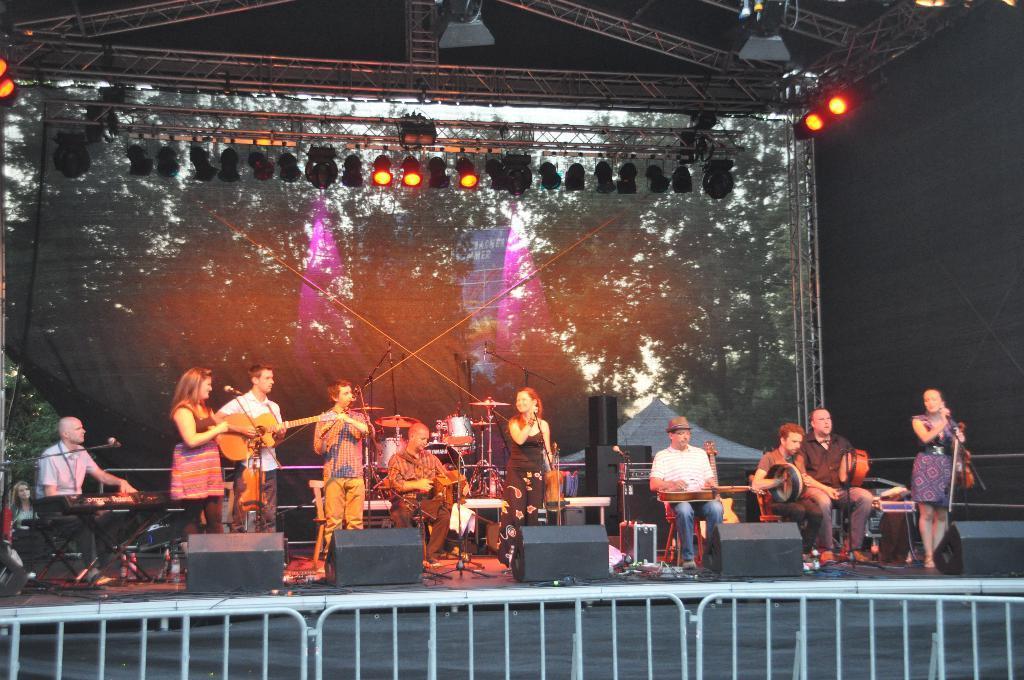In one or two sentences, can you explain what this image depicts? In this picture there are so many people musical instruments on the stage and in the background we observe an LCD screen and to the top of it we find lights fitted to the roof. This picture is clicked in a musical concert. 